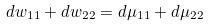Convert formula to latex. <formula><loc_0><loc_0><loc_500><loc_500>d w _ { 1 1 } + d w _ { 2 2 } = d \mu _ { 1 1 } + d \mu _ { 2 2 }</formula> 